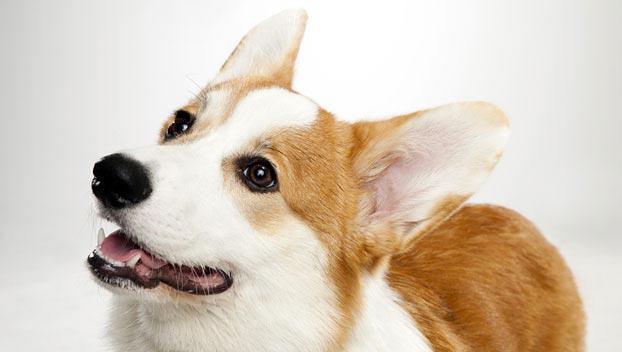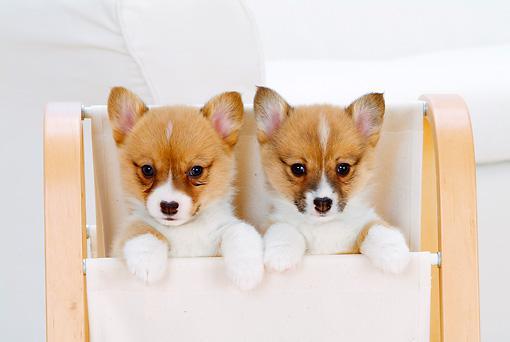The first image is the image on the left, the second image is the image on the right. For the images shown, is this caption "One image shows a pair of camera-facing dogs with their heads next to one another." true? Answer yes or no. Yes. The first image is the image on the left, the second image is the image on the right. Given the left and right images, does the statement "The right image contains exactly two dogs." hold true? Answer yes or no. Yes. 